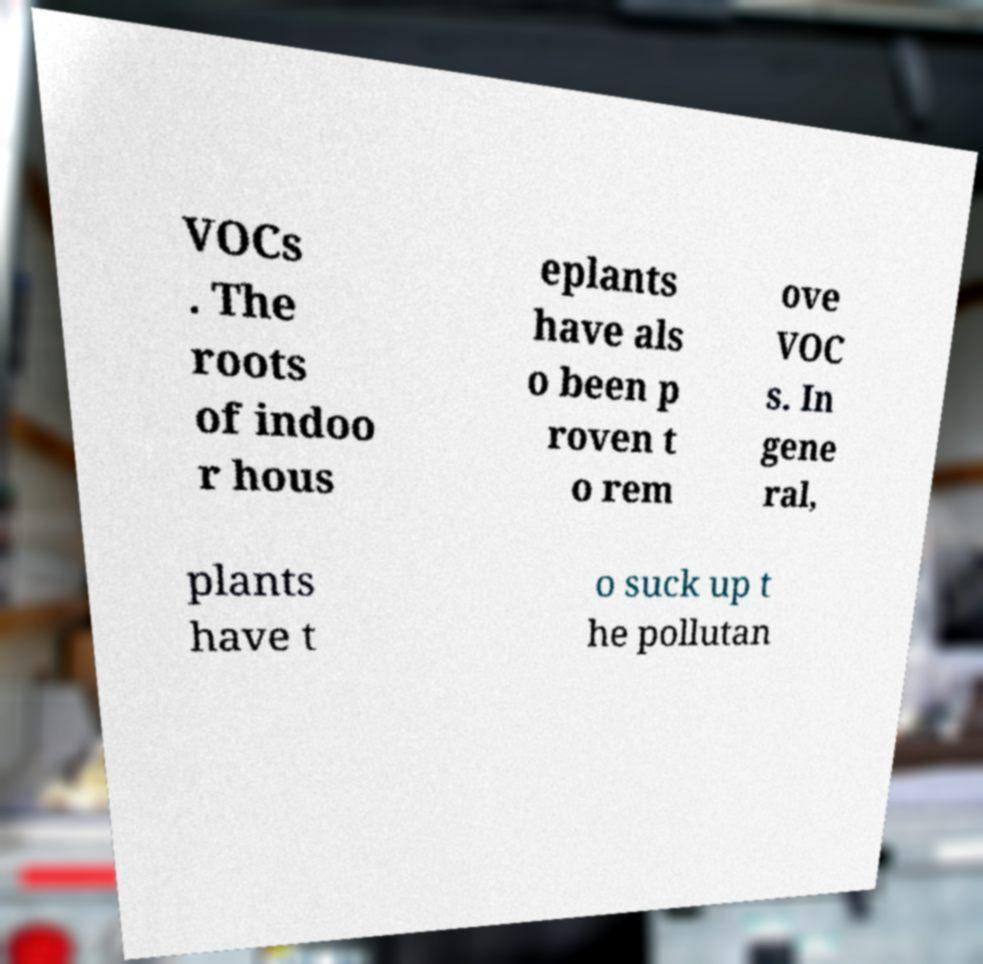Please identify and transcribe the text found in this image. VOCs . The roots of indoo r hous eplants have als o been p roven t o rem ove VOC s. In gene ral, plants have t o suck up t he pollutan 